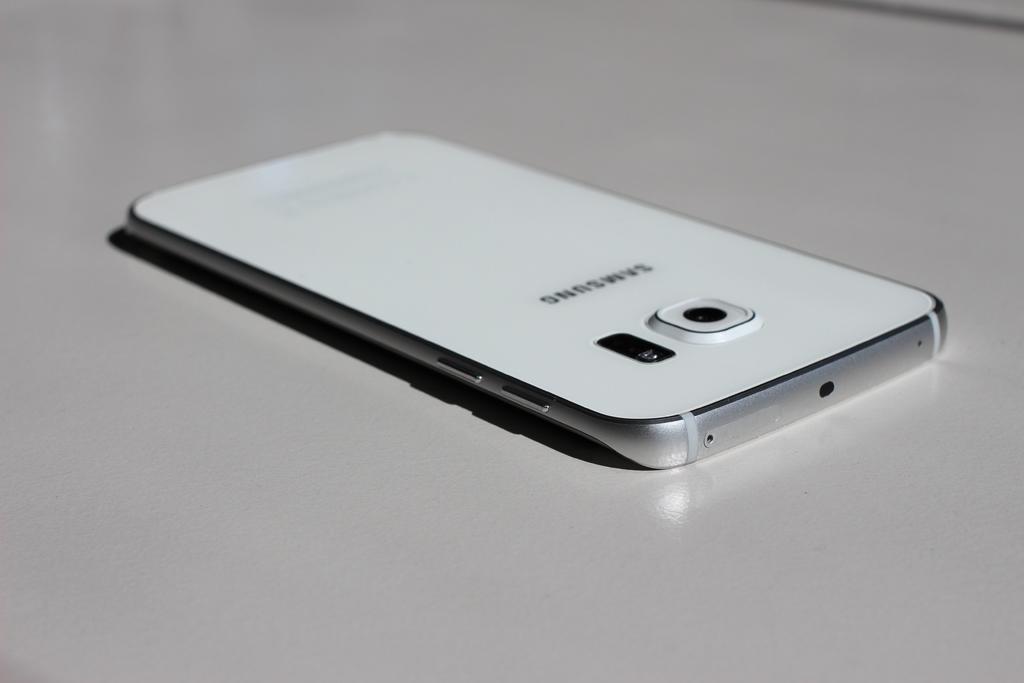What is the brand name on the back of the phone?
Your answer should be compact. Samsung. Is this an iphone or an android phone?
Give a very brief answer. Android. 